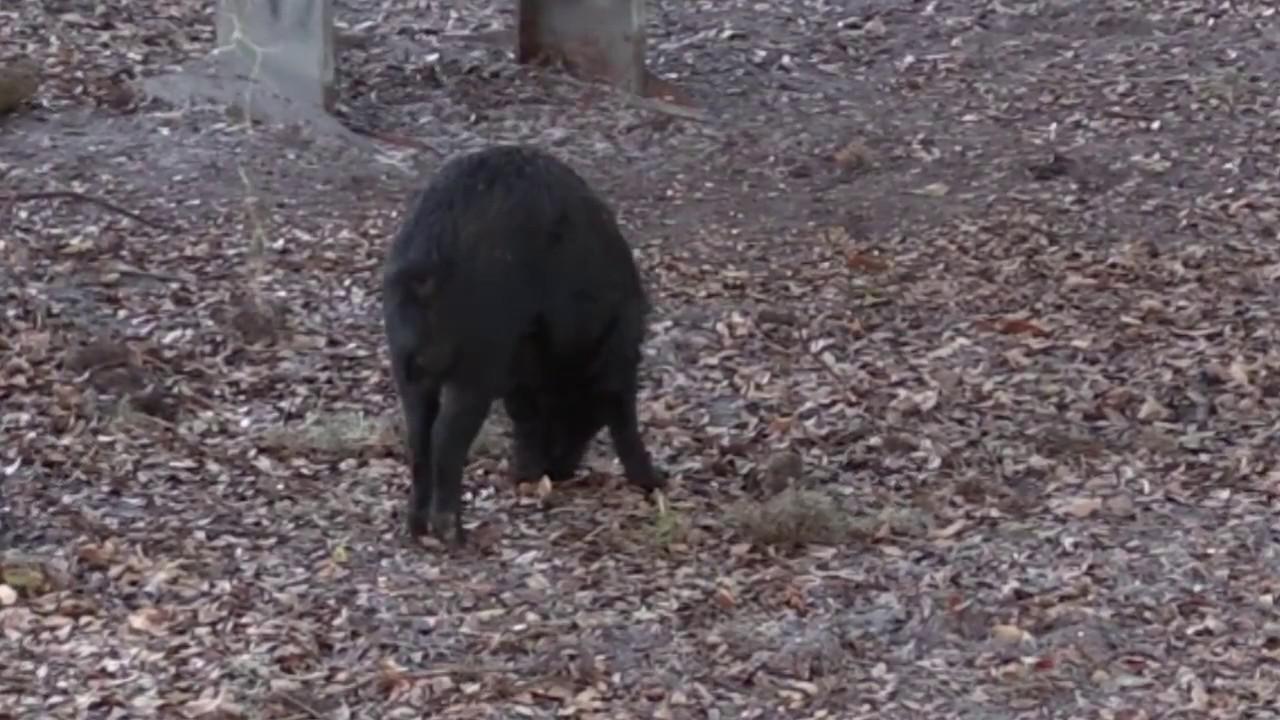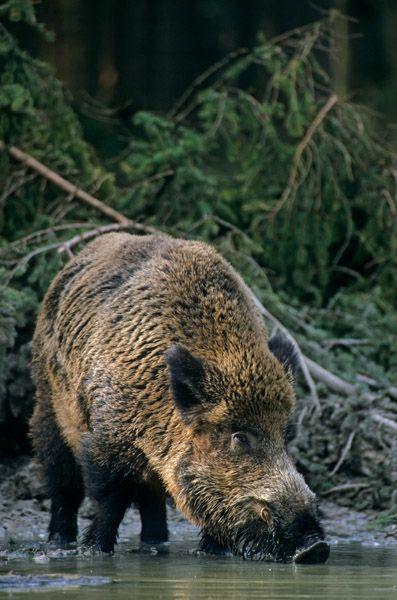The first image is the image on the left, the second image is the image on the right. Given the left and right images, does the statement "There are two pigs." hold true? Answer yes or no. Yes. The first image is the image on the left, the second image is the image on the right. Assess this claim about the two images: "a lone wartgog is standing in the water". Correct or not? Answer yes or no. Yes. 